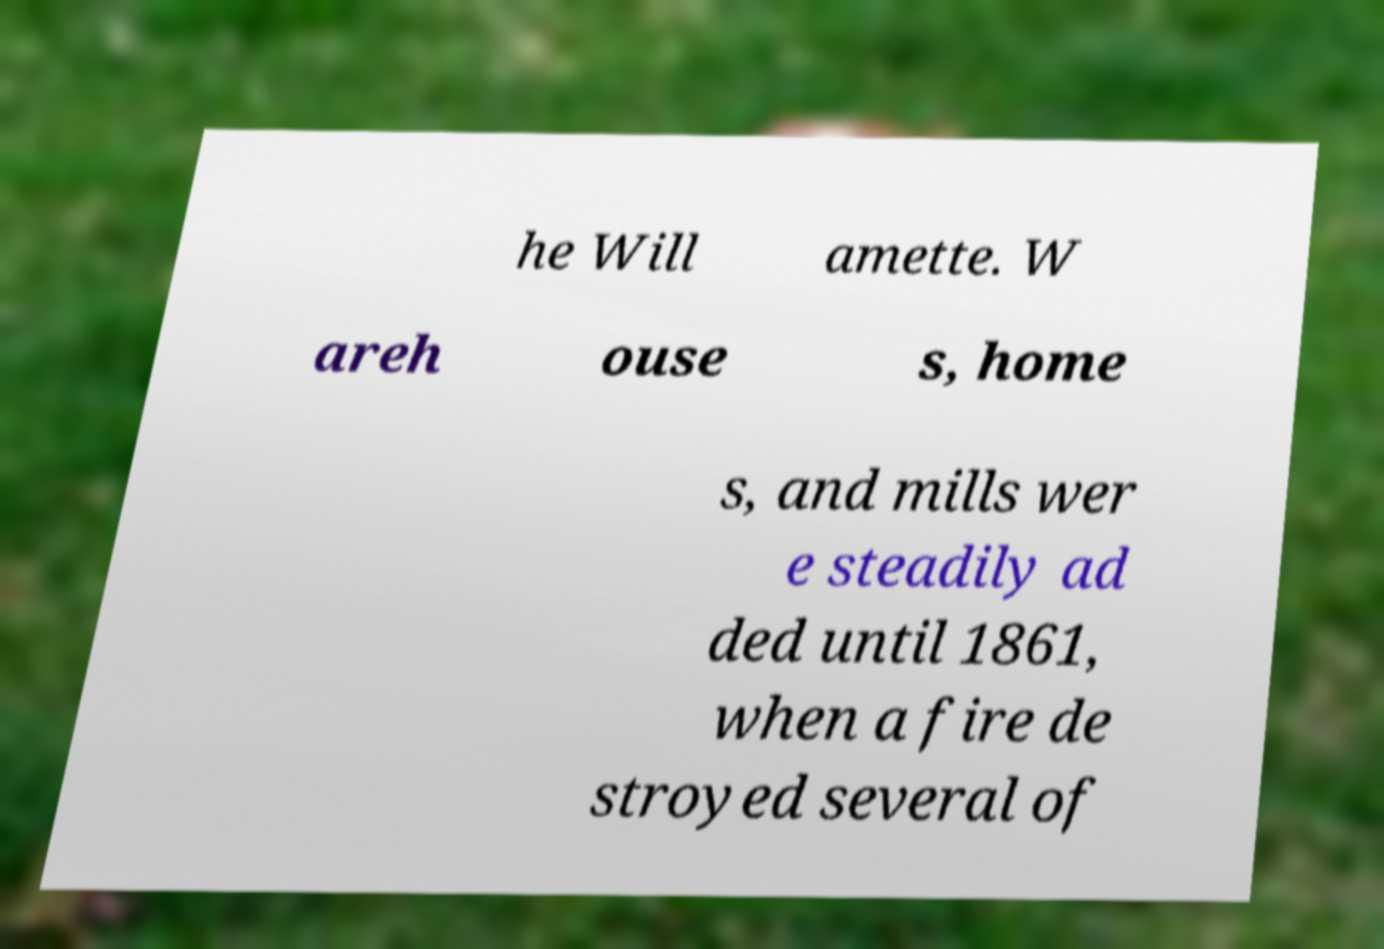Please read and relay the text visible in this image. What does it say? he Will amette. W areh ouse s, home s, and mills wer e steadily ad ded until 1861, when a fire de stroyed several of 